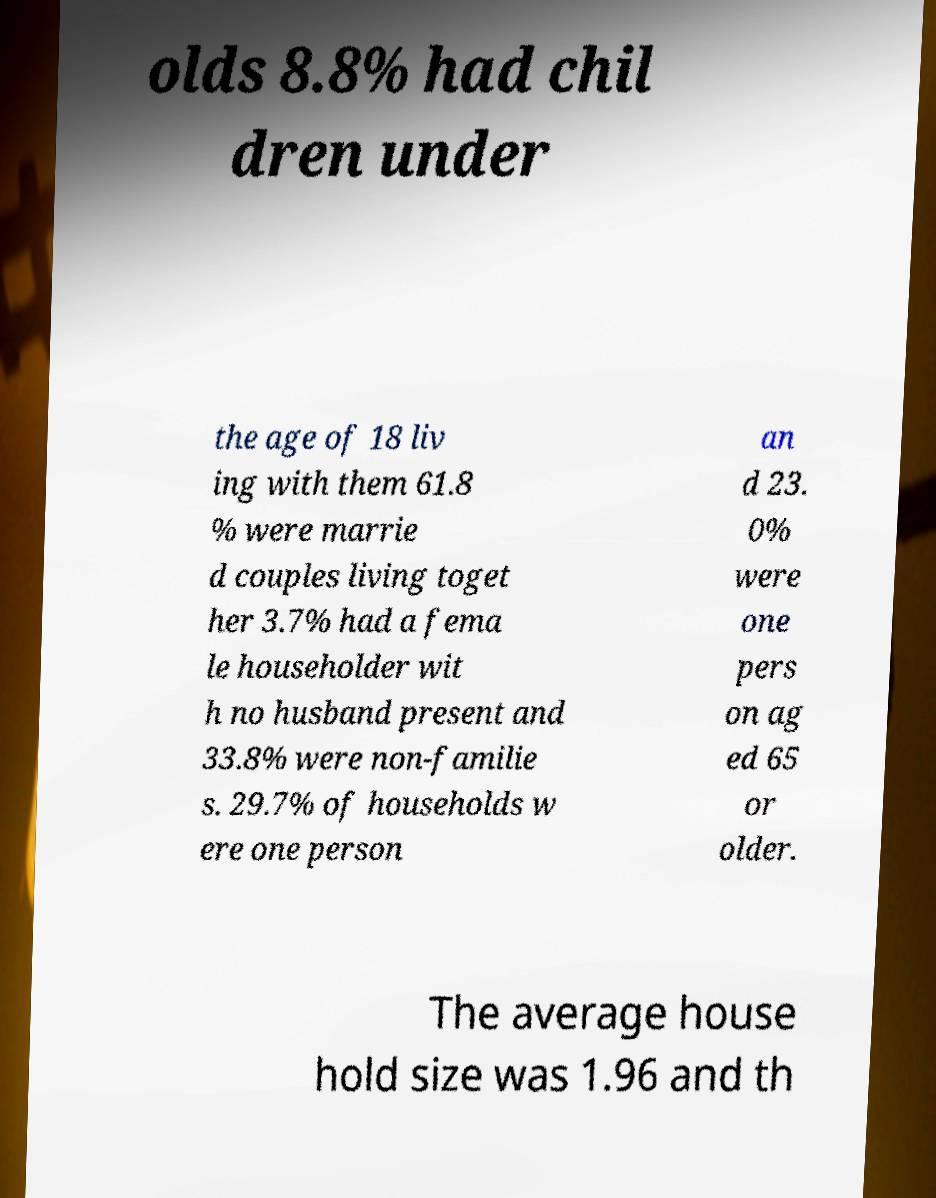Could you extract and type out the text from this image? olds 8.8% had chil dren under the age of 18 liv ing with them 61.8 % were marrie d couples living toget her 3.7% had a fema le householder wit h no husband present and 33.8% were non-familie s. 29.7% of households w ere one person an d 23. 0% were one pers on ag ed 65 or older. The average house hold size was 1.96 and th 